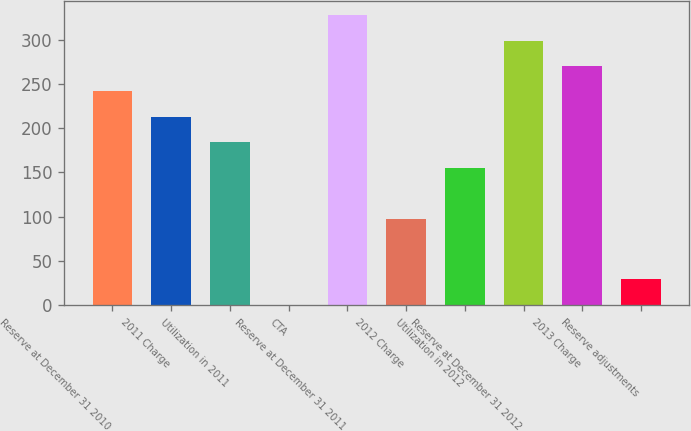Convert chart to OTSL. <chart><loc_0><loc_0><loc_500><loc_500><bar_chart><fcel>Reserve at December 31 2010<fcel>2011 Charge<fcel>Utilization in 2011<fcel>CTA<fcel>Reserve at December 31 2011<fcel>2012 Charge<fcel>Utilization in 2012<fcel>Reserve at December 31 2012<fcel>2013 Charge<fcel>Reserve adjustments<nl><fcel>241.5<fcel>212.8<fcel>184.1<fcel>1<fcel>327.6<fcel>98<fcel>155.4<fcel>298.9<fcel>270.2<fcel>29.7<nl></chart> 